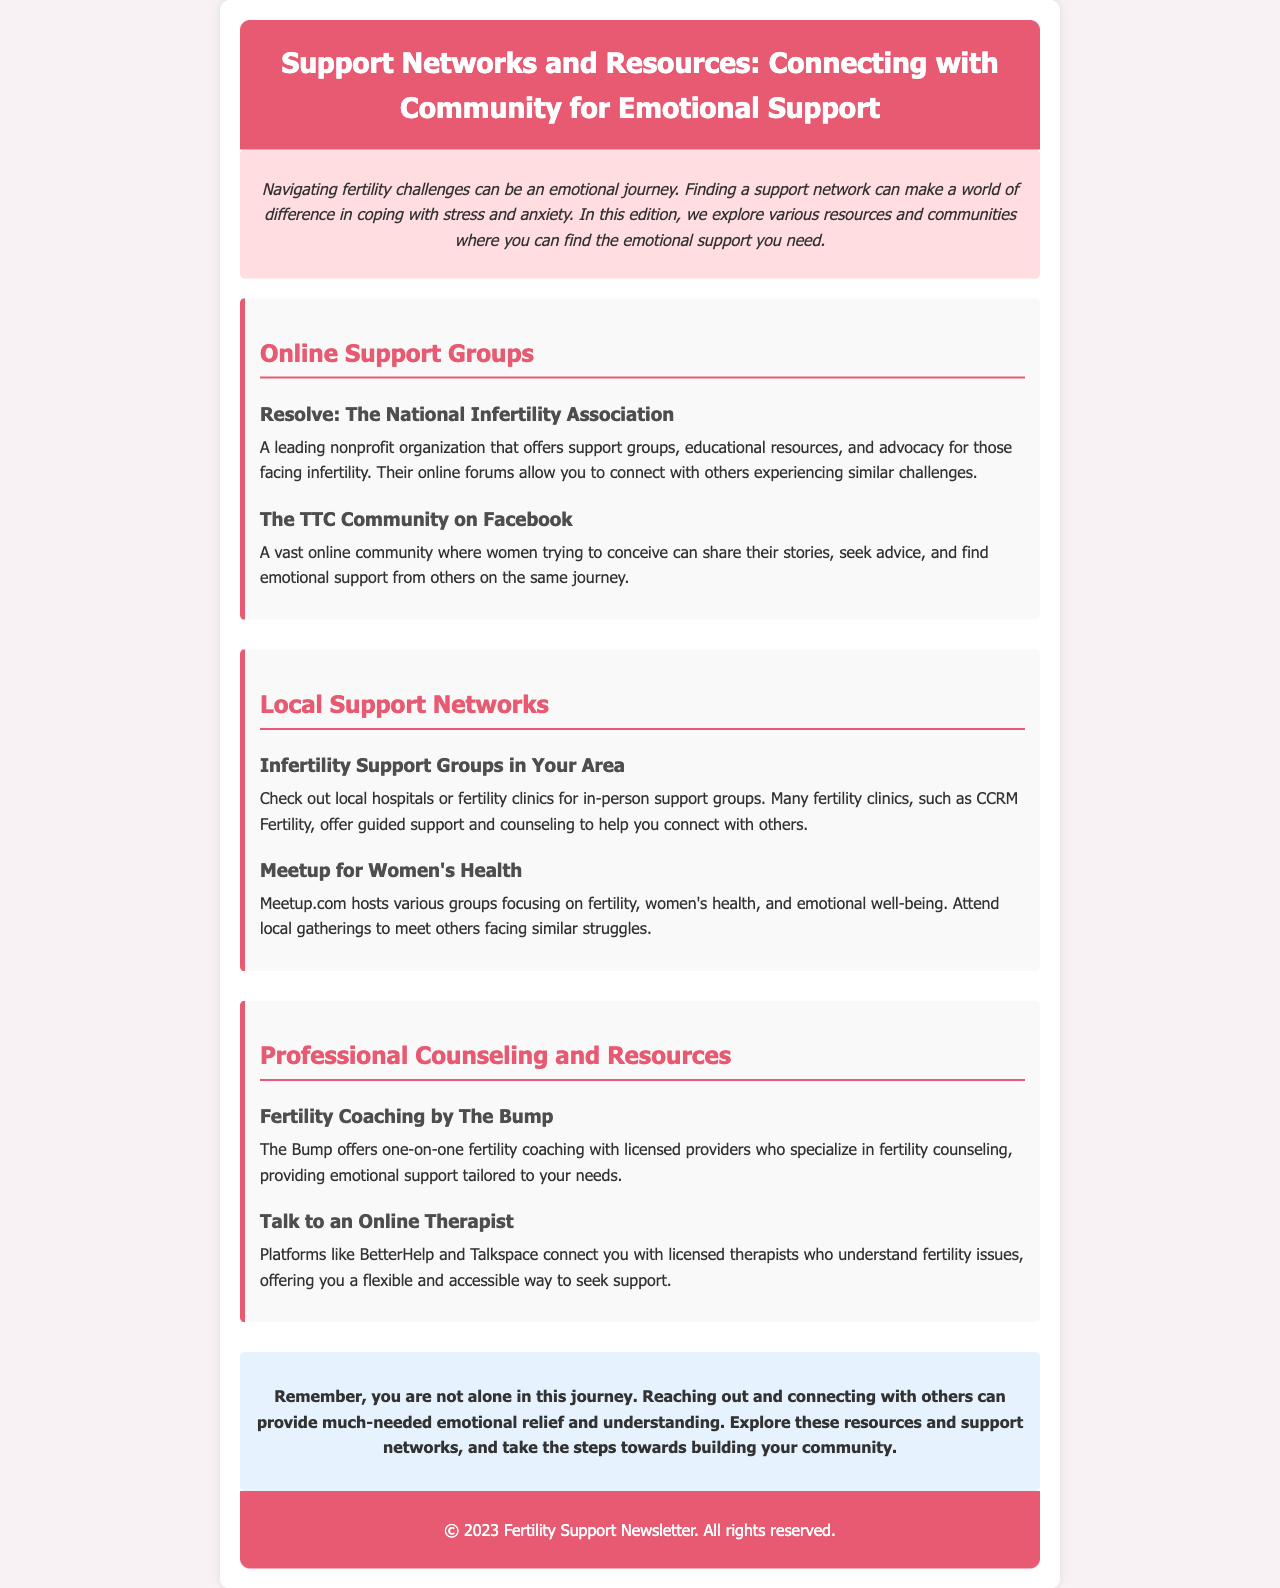What is the title of the newsletter? The title of the newsletter is found in the header section at the top of the document.
Answer: Support Networks and Resources: Connecting with Community for Emotional Support Who is the organization mentioned in the online support groups? One specific organization listed in the online support groups section is identified within the resources.
Answer: Resolve: The National Infertility Association What is one of the online platforms mentioned for connecting with therapists? The document specifies platforms for online therapy in the professional counseling section.
Answer: BetterHelp What type of support can you expect from The Bump? This support is detailed in the professional counseling section, describing what The Bump offers.
Answer: One-on-one fertility coaching How can you find local support groups? The document notes where you can check to locate these groups in the local support networks section.
Answer: Local hospitals or fertility clinics What background color is used for the introductory paragraph? The introductory paragraph's background color is specified in the style of the document.
Answer: #ffdde1 What is the purpose of the newsletter? The introductory section of the newsletter outlines its primary goal.
Answer: Provide emotional support How does the document conclude? The conclusion is described in the final section, summarizing the newsletter’s message.
Answer: You are not alone in this journey 